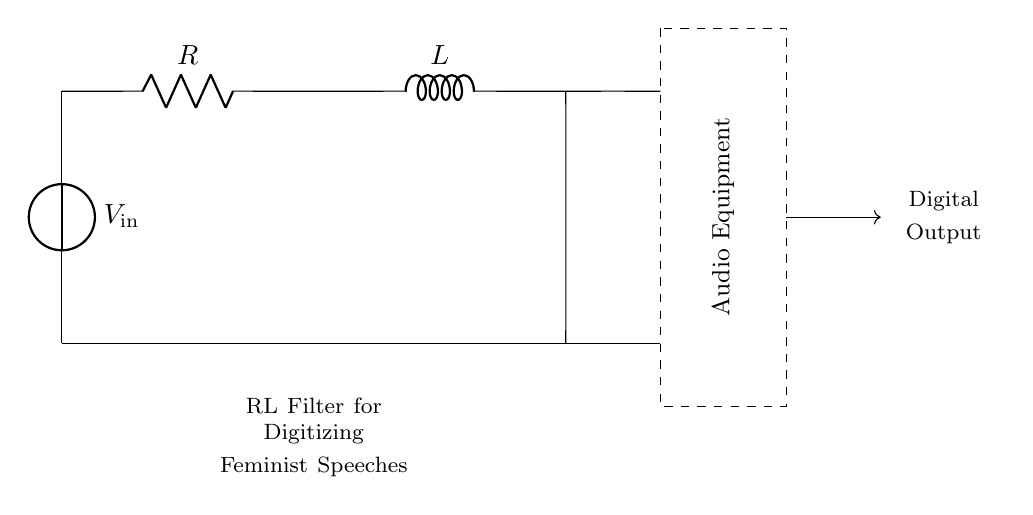What are the components of the circuit? The circuit contains a voltage source, a resistor, and an inductor. These components are connected in series.
Answer: voltage source, resistor, inductor What is the purpose of this circuit? The circuit functions as an RL filter designed for digitizing feminist speeches in audio equipment. This is indicated by the note at the bottom of the diagram.
Answer: RL filter for digitizing feminist speeches What is the voltage source labeled as? The voltage source in the circuit is labeled as V_in, indicating it is the input voltage to the circuit.
Answer: V_in In which direction does the current flow? The current flows from the voltage source through the resistor to the inductor, and then returns to the voltage source, forming a complete loop.
Answer: clockwise What type of filter is represented in this circuit? This circuit is an RL low-pass filter, which allows low-frequency signals to pass while attenuating high-frequency signals. This is due to the properties of resistors and inductors in series.
Answer: low-pass filter How does adding a larger inductor value affect the circuit’s performance? Increasing the inductor value will decrease the cut-off frequency of the filter. A larger inductor stores more energy and resists changes in current more effectively, creating a lower cutoff frequency.
Answer: decreases cut-off frequency What is the intended output of this circuit? The intended output of the circuit is digital, as indicated by the label next to the output path in the diagram. The audio equipment processes the analog signal for digital output.
Answer: digital output 